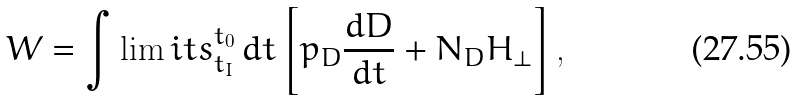<formula> <loc_0><loc_0><loc_500><loc_500>W = \int \lim i t s _ { t _ { I } } ^ { t _ { 0 } } \, d t \left [ p _ { D } \frac { d D } { d t } + N _ { D } { H } _ { \bot } \right ] ,</formula> 